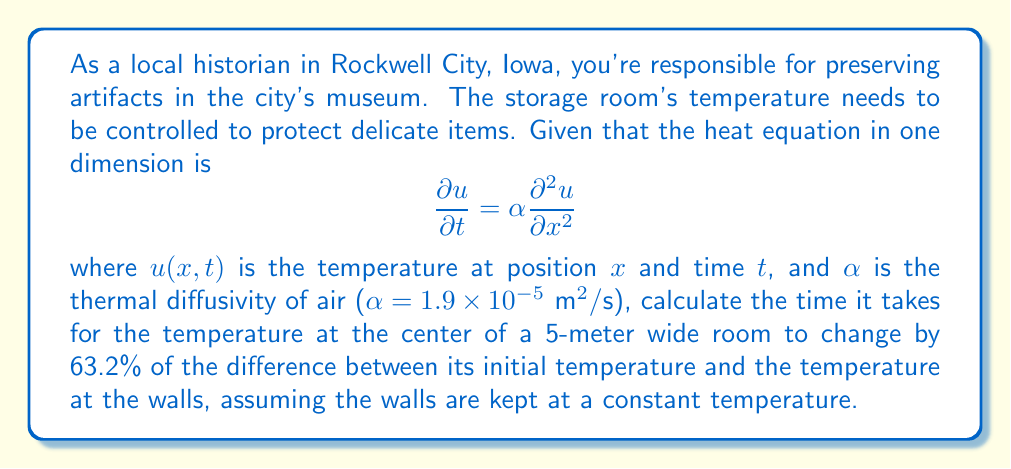Show me your answer to this math problem. To solve this problem, we'll use the solution to the heat equation for a finite slab with constant temperature at the boundaries:

1) The solution for the temperature distribution is given by:
   $$u(x,t) = u_f + \sum_{n=1}^{\infty} A_n \sin(\frac{n\pi x}{L}) e^{-\alpha (\frac{n\pi}{L})^2 t}$$
   where $u_f$ is the final (wall) temperature, $L$ is the width of the room, and $A_n$ are coefficients determined by initial conditions.

2) At the center of the room ($x = L/2$), this simplifies to:
   $$u(L/2,t) = u_f + \sum_{n \text{ odd}} A_n \sin(\frac{n\pi}{2}) e^{-\alpha (\frac{n\pi}{L})^2 t}$$

3) The first term ($n=1$) dominates the series for large times, so we can approximate:
   $$u(L/2,t) \approx u_f + A_1 e^{-\alpha (\frac{\pi}{L})^2 t}$$

4) The time constant $\tau$ of this exponential decay is:
   $$\tau = \frac{L^2}{\alpha \pi^2}$$

5) At time $t = \tau$, the temperature difference has decreased by a factor of $e^{-1} \approx 0.368$, or changed by 63.2%.

6) Plugging in the values:
   $$\tau = \frac{(5 \text{ m})^2}{(1.9 \times 10^{-5} \text{ m}^2/\text{s}) \pi^2} \approx 4,188 \text{ s}$$

7) Converting to hours:
   $$4,188 \text{ s} \times \frac{1 \text{ hour}}{3600 \text{ s}} \approx 1.16 \text{ hours}$$

Therefore, it takes approximately 1.16 hours for the temperature at the center of the room to change by 63.2% of the initial temperature difference.
Answer: 1.16 hours 